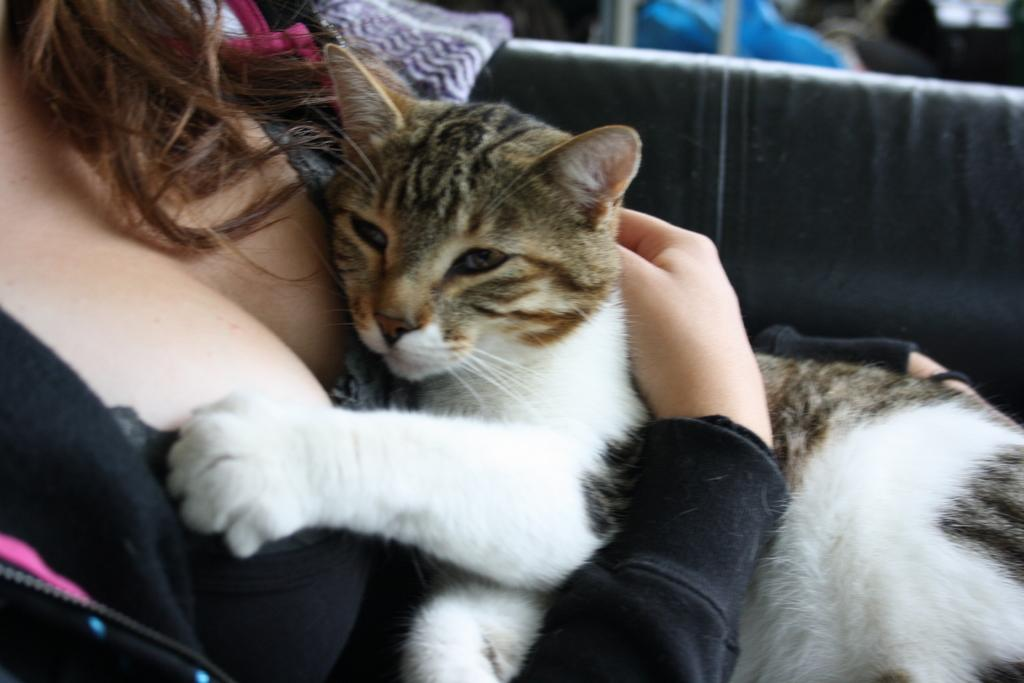What is the main subject of the image? The main subject of the image is a woman. What is the woman doing in the image? The woman is sitting in the image. What is the woman holding in her hands? The woman is holding a cat in her hands. What type of banana is the woman holding in the image? There is no banana present in the image; the woman is holding a cat. Is the woman a spy in the image? There is no information in the image to suggest that the woman is a spy. 